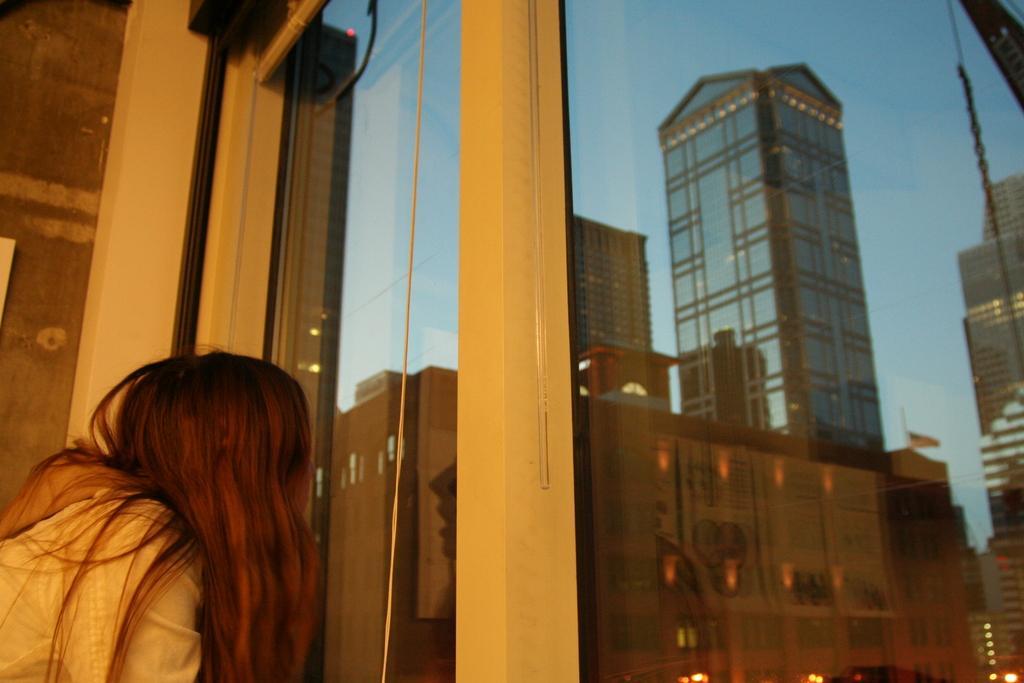Describe this image in one or two sentences. In this picture we can see a person at the window, buildings, flag, lights and in the background we can see the sky. 